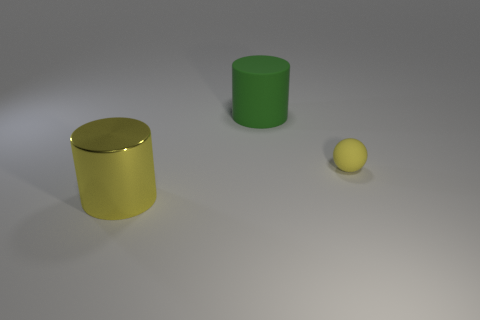Add 2 big objects. How many objects exist? 5 Subtract all green cylinders. How many cylinders are left? 1 Subtract all cylinders. How many objects are left? 1 Subtract all brown cylinders. Subtract all yellow spheres. How many cylinders are left? 2 Subtract all yellow balls. How many yellow cylinders are left? 1 Subtract all green matte objects. Subtract all tiny yellow rubber objects. How many objects are left? 1 Add 3 large cylinders. How many large cylinders are left? 5 Add 1 large yellow metal things. How many large yellow metal things exist? 2 Subtract 0 blue balls. How many objects are left? 3 